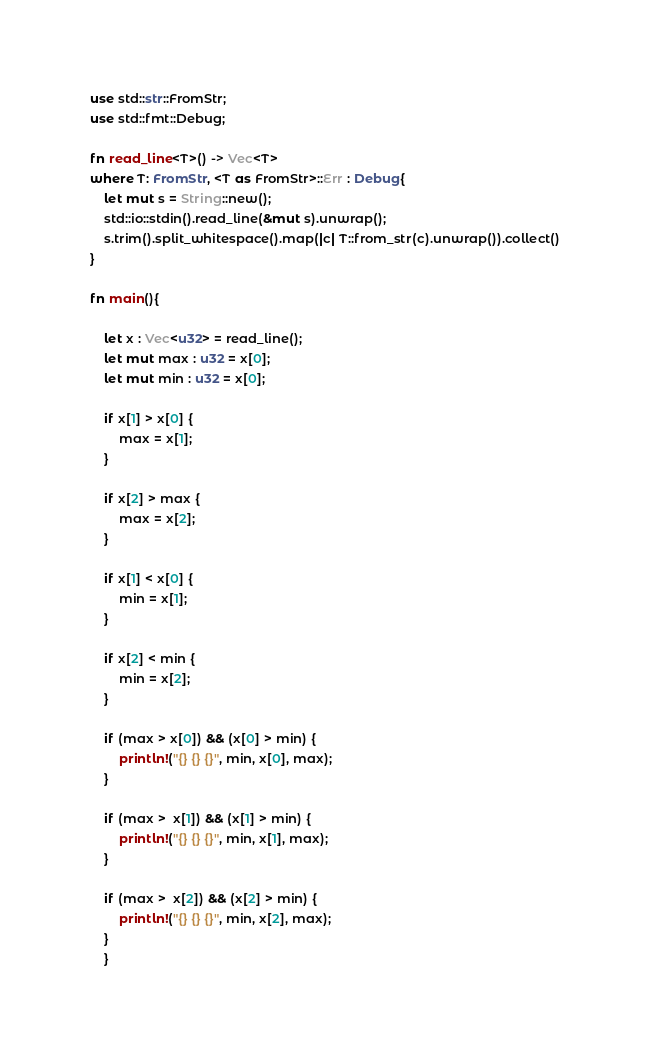Convert code to text. <code><loc_0><loc_0><loc_500><loc_500><_Rust_>use std::str::FromStr;
use std::fmt::Debug;
 
fn read_line<T>() -> Vec<T>
where T: FromStr, <T as FromStr>::Err : Debug{
    let mut s = String::new();
    std::io::stdin().read_line(&mut s).unwrap();
    s.trim().split_whitespace().map(|c| T::from_str(c).unwrap()).collect()
}
 
fn main(){
 
	let x : Vec<u32> = read_line();
	let mut max : u32 = x[0]; 
	let mut min : u32 = x[0];
	
	if x[1] > x[0] {
		max = x[1];
	}
	
	if x[2] > max {
		max = x[2];
	}
	
	if x[1] < x[0] {
		min = x[1];
	}
	
	if x[2] < min {
		min = x[2];
	}
	
	if (max > x[0]) && (x[0] > min) {
		println!("{} {} {}", min, x[0], max);
	}
	
	if (max >  x[1]) && (x[1] > min) {
		println!("{} {} {}", min, x[1], max);
	}
	
	if (max >  x[2]) && (x[2] > min) {
		println!("{} {} {}", min, x[2], max);
	}
	}
</code> 